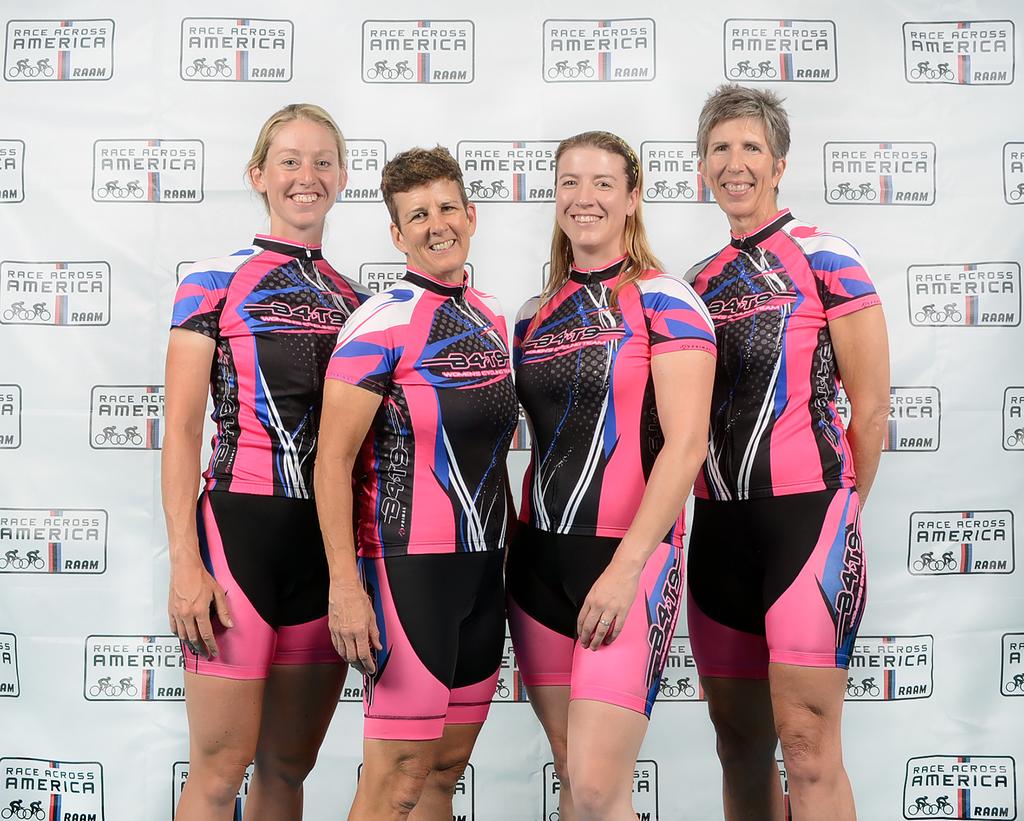Race across where according to the background?
Give a very brief answer. America. 